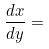Convert formula to latex. <formula><loc_0><loc_0><loc_500><loc_500>\frac { d x } { d y } =</formula> 